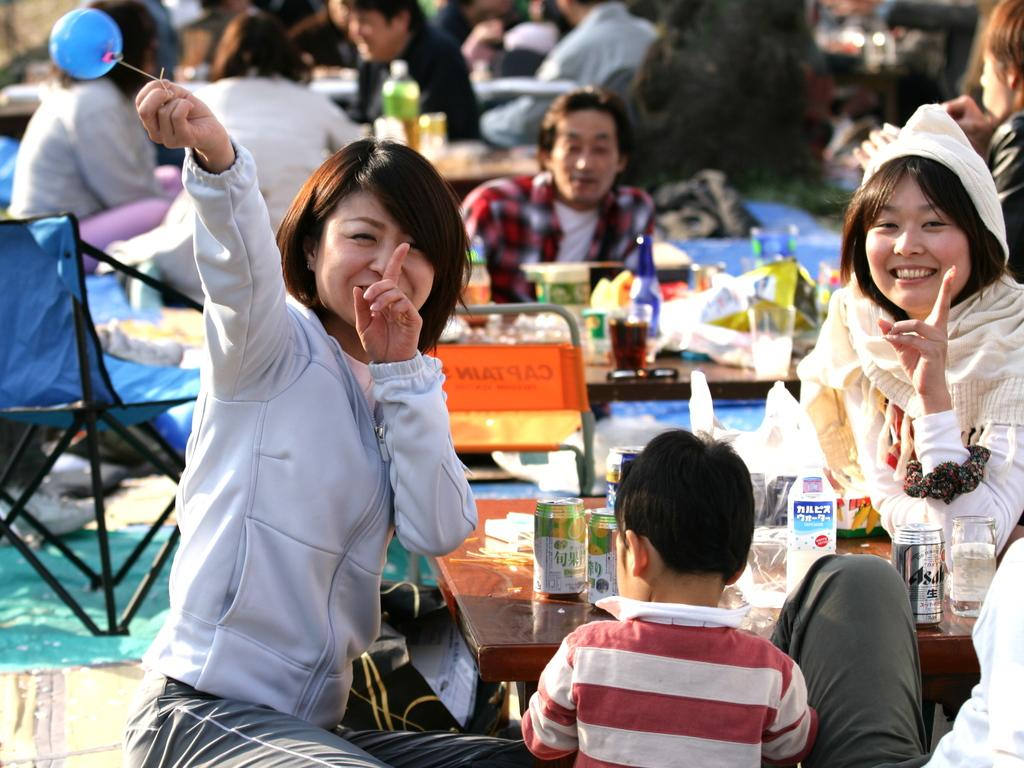What are the people in the image doing? The people in the image are sitting in chairs. What is in front of the people? There is a table in front of the people. What can be found on the table? There are eatables and drinks on the table. What type of foot is visible on the table in the image? There is no foot visible on the table in the image. What invention is being used by the people in the image? The provided facts do not mention any specific invention being used by the people in the image. 